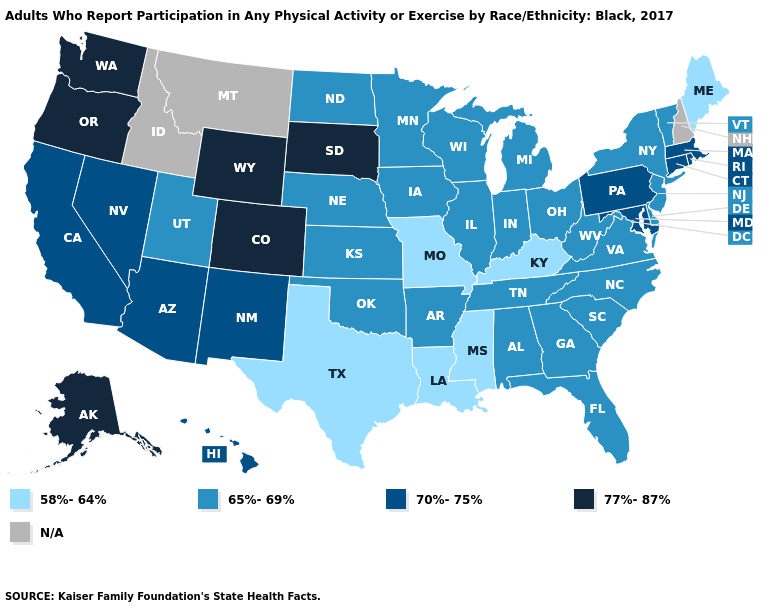How many symbols are there in the legend?
Quick response, please. 5. What is the value of Connecticut?
Write a very short answer. 70%-75%. Which states have the lowest value in the USA?
Quick response, please. Kentucky, Louisiana, Maine, Mississippi, Missouri, Texas. Among the states that border California , which have the highest value?
Concise answer only. Oregon. What is the value of West Virginia?
Quick response, please. 65%-69%. What is the value of Wyoming?
Answer briefly. 77%-87%. What is the lowest value in the USA?
Short answer required. 58%-64%. What is the value of Tennessee?
Answer briefly. 65%-69%. Name the states that have a value in the range 65%-69%?
Answer briefly. Alabama, Arkansas, Delaware, Florida, Georgia, Illinois, Indiana, Iowa, Kansas, Michigan, Minnesota, Nebraska, New Jersey, New York, North Carolina, North Dakota, Ohio, Oklahoma, South Carolina, Tennessee, Utah, Vermont, Virginia, West Virginia, Wisconsin. What is the highest value in states that border Illinois?
Concise answer only. 65%-69%. Among the states that border Vermont , which have the highest value?
Short answer required. Massachusetts. Among the states that border Colorado , which have the highest value?
Be succinct. Wyoming. Name the states that have a value in the range 77%-87%?
Short answer required. Alaska, Colorado, Oregon, South Dakota, Washington, Wyoming. 